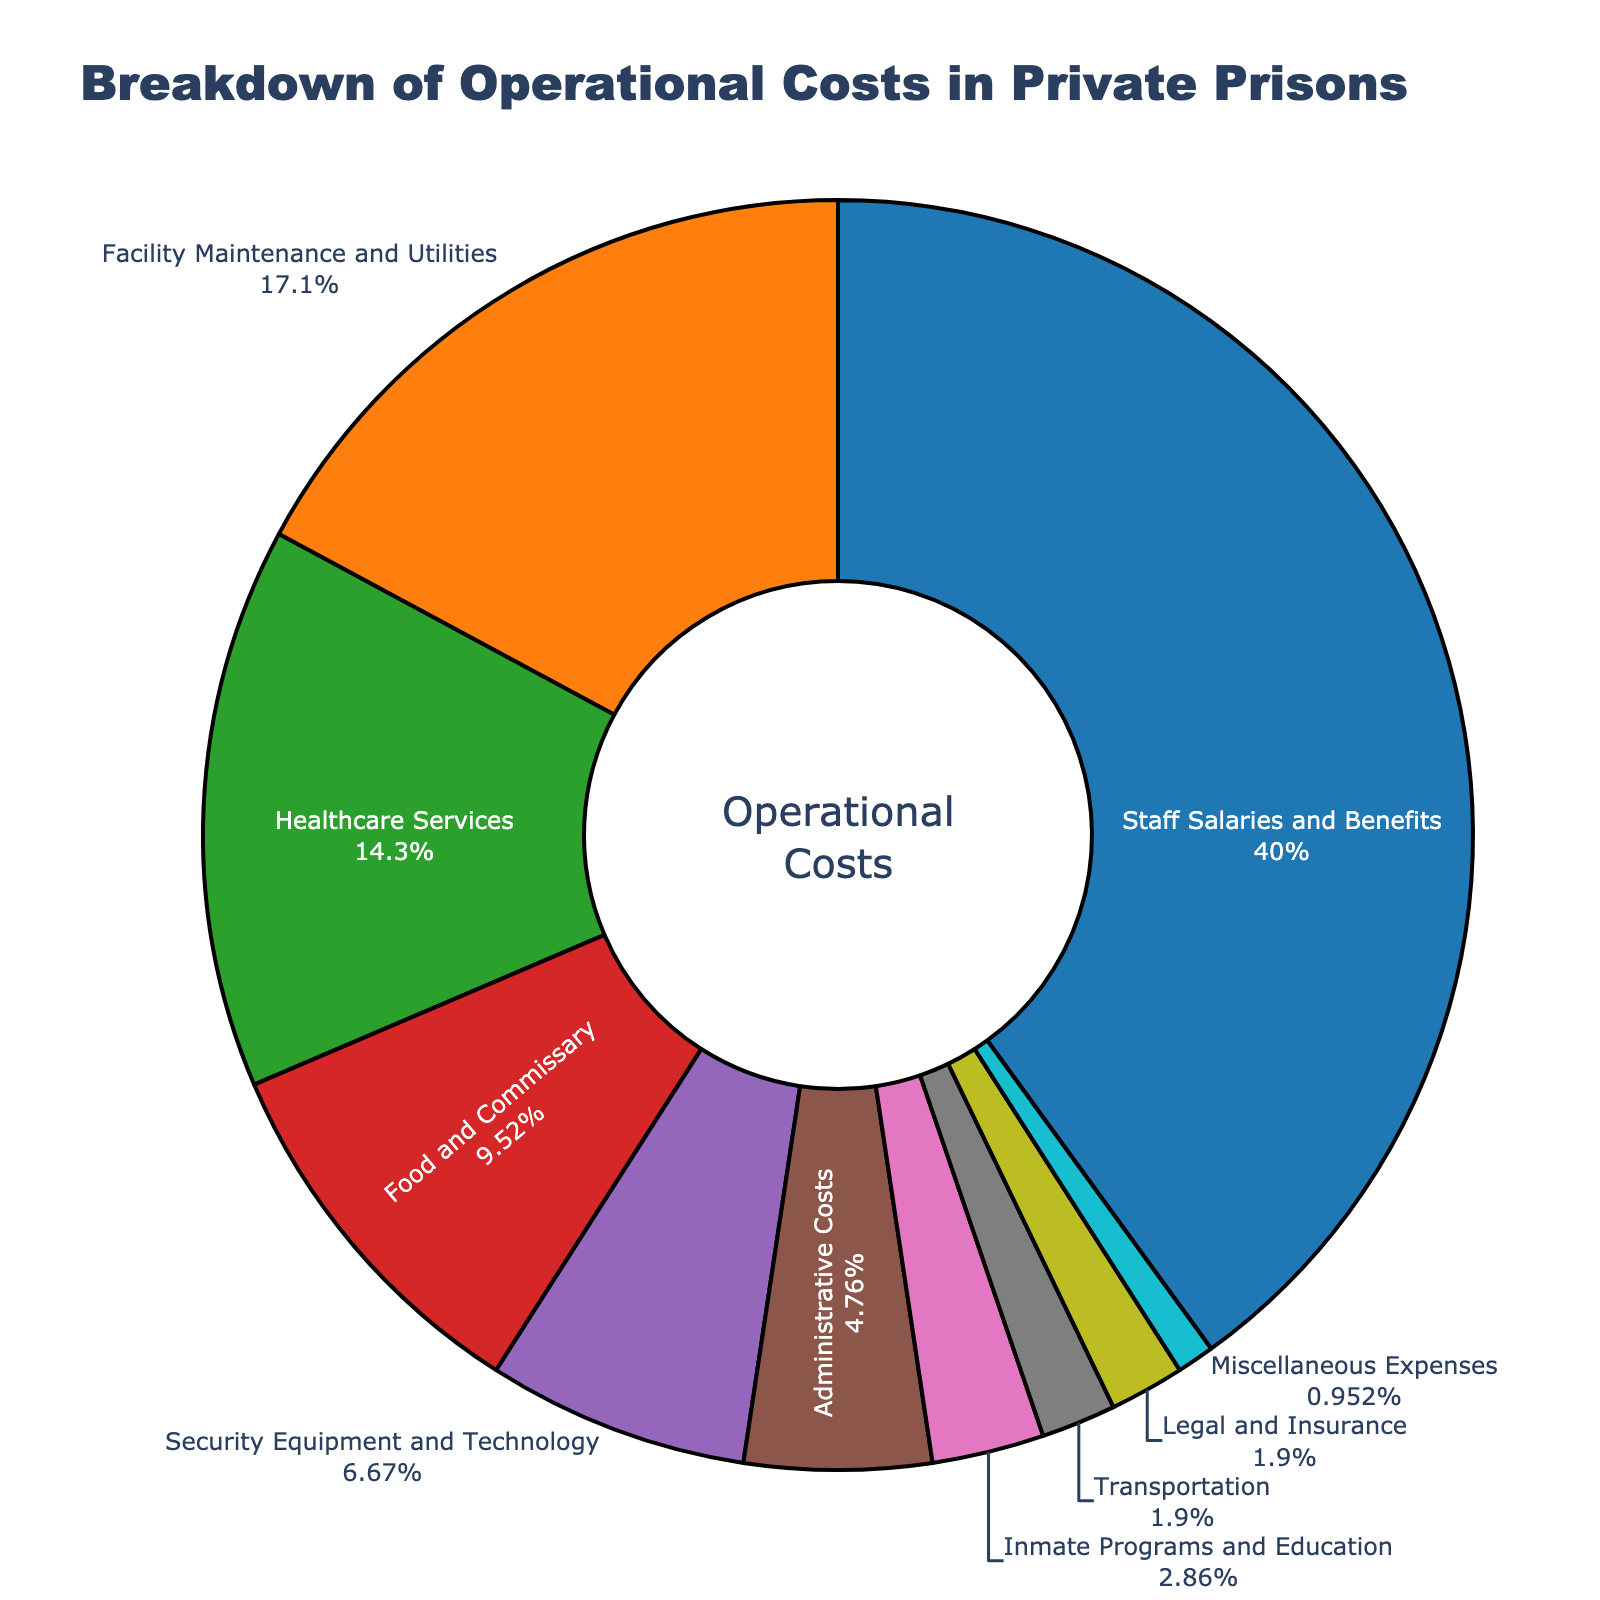Which category has the highest percentage of operational costs? Inspecting the chart, the category with the largest slice and the highest percentage label is "Staff Salaries and Benefits."
Answer: Staff Salaries and Benefits Which category contributes the lowest percentage to operational costs? By observing the smallest slice in the pie chart, the category with the lowest percentage is "Miscellaneous Expenses."
Answer: Miscellaneous Expenses What percentage of operational costs is spent on Security Equipment and Technology combined with Transportation? Adding the percentages for these categories: Security Equipment and Technology (7%) + Transportation (2%) results in 9%.
Answer: 9% Is the percentage spent on Healthcare Services greater than on Food and Commissary? Comparing the slices and their percentages, Healthcare Services is 15% and Food and Commissary is 10%. So, 15% is greater than 10%.
Answer: Yes Combined, do Staff Salaries and Benefits, Facility Maintenance and Utilities, and Healthcare Services make up more than 60% of the total costs? Summing up these categories: Staff Salaries and Benefits (42%) + Facility Maintenance and Utilities (18%) + Healthcare Services (15%). The sum is 75%, which is more than 60%.
Answer: Yes Which category’s slice color is represented as a bright orange? By observing the color associated with each segment, bright orange corresponds to "Facility Maintenance and Utilities."
Answer: Facility Maintenance and Utilities How much more is spent on Staff Salaries and Benefits compared to Administrative Costs? Subtract the percentages: Staff Salaries and Benefits (42%) - Administrative Costs (5%) equals 37%.
Answer: 37% List the categories that each make up less than 5% of the operational costs. Categories with slices representing less than 5% are "Inmate Programs and Education," "Transportation," "Legal and Insurance," and "Miscellaneous Expenses."
Answer: Inmate Programs and Education, Transportation, Legal and Insurance, Miscellaneous Expenses What is the combined percentage of Administrative Costs, Inmate Programs and Education, and Legal and Insurance? Summing these percentages: Administrative Costs (5%) + Inmate Programs and Education (3%) + Legal and Insurance (2%) is equal to 10%.
Answer: 10% Is the percentage of costs allocated to Food and Commissary equal to half of the costs for Staff Salaries and Benefits? Dividing the percentage for Staff Salaries and Benefits by 2 gives 42% / 2 = 21%. The percentage for Food and Commissary is 10%, which is less than 21%.
Answer: No 